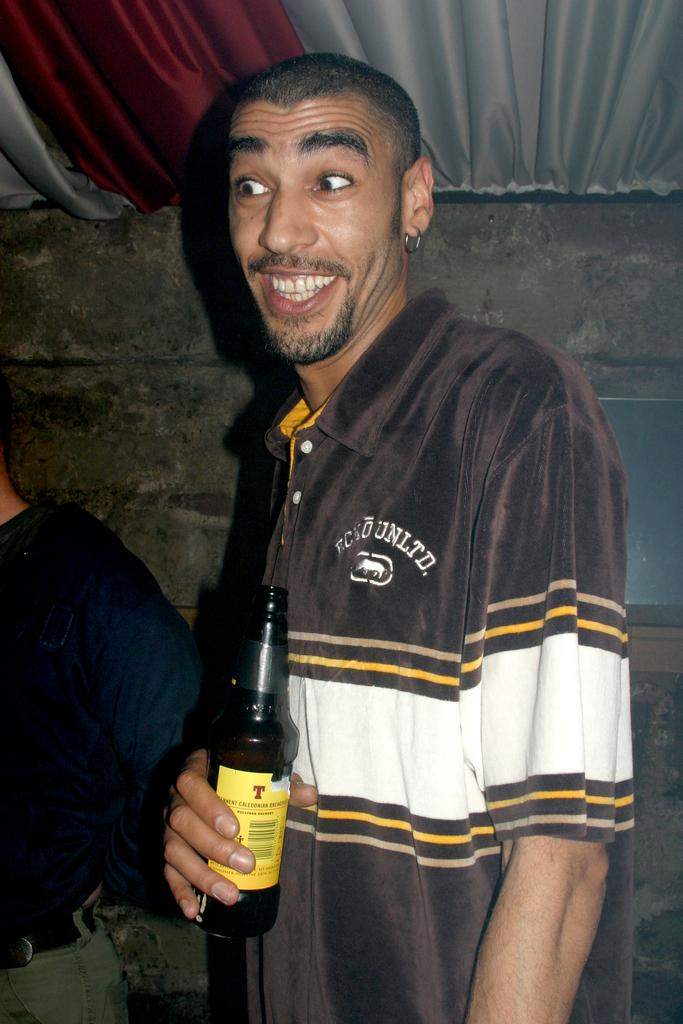What is the main subject of the image? The main subject of the image is a man. Can you describe the man's clothing? The man is wearing a brown and white shirt. What is the man's facial expression? The man is smiling. What is the man holding in the image? The man is holding a bottle. Can you describe the background of the image? There is a wall and a cloth in the background of the image. How many people are present in the image? There are two people in the image. What type of destruction is the man causing in the image? There is no destruction present in the image; the man is simply holding a bottle and smiling. What kind of attraction is the man creating in the image? The image does not depict any specific attraction; it simply shows a man smiling and holding a bottle. 